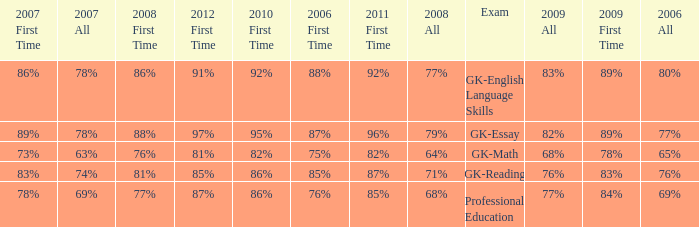What is the percentage for all in 2007 when all in 2006 was 65%? 63%. 